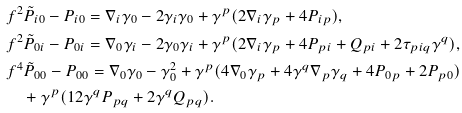Convert formula to latex. <formula><loc_0><loc_0><loc_500><loc_500>& f ^ { 2 } \tilde { P } _ { i 0 } - P _ { i 0 } = \nabla _ { i } \gamma _ { 0 } - 2 \gamma _ { i } \gamma _ { 0 } + \gamma ^ { p } ( 2 \nabla _ { i } \gamma _ { p } + 4 P _ { i p } ) , \\ & f ^ { 2 } \tilde { P } _ { 0 i } - P _ { 0 i } = \nabla _ { 0 } \gamma _ { i } - 2 \gamma _ { 0 } \gamma _ { i } + \gamma ^ { p } ( 2 \nabla _ { i } \gamma _ { p } + 4 P _ { p i } + Q _ { p i } + 2 \tau _ { p i q } \gamma ^ { q } ) , \\ & f ^ { 4 } \tilde { P } _ { 0 0 } - P _ { 0 0 } = \nabla _ { 0 } \gamma _ { 0 } - \gamma _ { 0 } ^ { 2 } + \gamma ^ { p } ( 4 \nabla _ { 0 } \gamma _ { p } + 4 \gamma ^ { q } \nabla _ { p } \gamma _ { q } + 4 P _ { 0 p } + 2 P _ { p 0 } ) \\ & \quad + \gamma ^ { p } ( 1 2 \gamma ^ { q } P _ { p q } + 2 \gamma ^ { q } Q _ { p q } ) .</formula> 